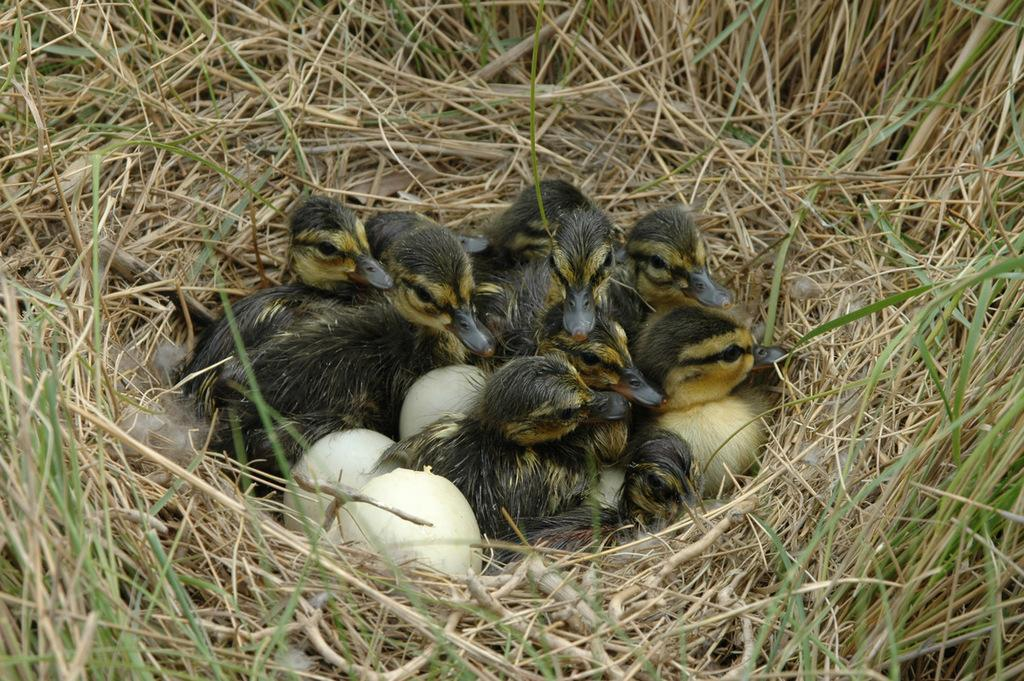What can be found in the picture? There is a nest, birds, eggs, and grass visible in the picture. Can you describe the nest in the picture? The nest is in the picture, but its specific characteristics are not mentioned in the provided facts. What are the birds doing in the picture? The provided facts do not specify the actions of the birds in the picture. What type of vegetation is visible in the picture? Grass is visible in the picture. How many sisters are present in the picture? There is no mention of sisters in the provided facts, so we cannot determine their presence in the image. What type of cakes are being served in the picture? There is no mention of cakes in the provided facts, so we cannot determine their presence in the image. 